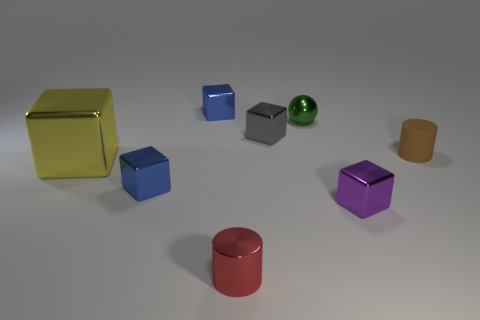Is the number of metal cylinders less than the number of tiny cyan shiny cylinders?
Ensure brevity in your answer.  No. Is the color of the metallic object in front of the tiny purple object the same as the small ball?
Give a very brief answer. No. The tiny cylinder that is made of the same material as the yellow object is what color?
Ensure brevity in your answer.  Red. Does the purple metallic thing have the same size as the brown thing?
Offer a very short reply. Yes. What is the large yellow object made of?
Give a very brief answer. Metal. There is a red object that is the same size as the purple metallic object; what material is it?
Your answer should be compact. Metal. Are there any red metallic cylinders of the same size as the gray object?
Provide a succinct answer. Yes. Are there an equal number of brown things that are to the right of the purple block and rubber cylinders behind the red cylinder?
Your answer should be compact. Yes. Are there more big brown rubber cubes than large yellow metal blocks?
Provide a succinct answer. No. What number of shiny objects are either small purple things or blue objects?
Provide a short and direct response. 3. 